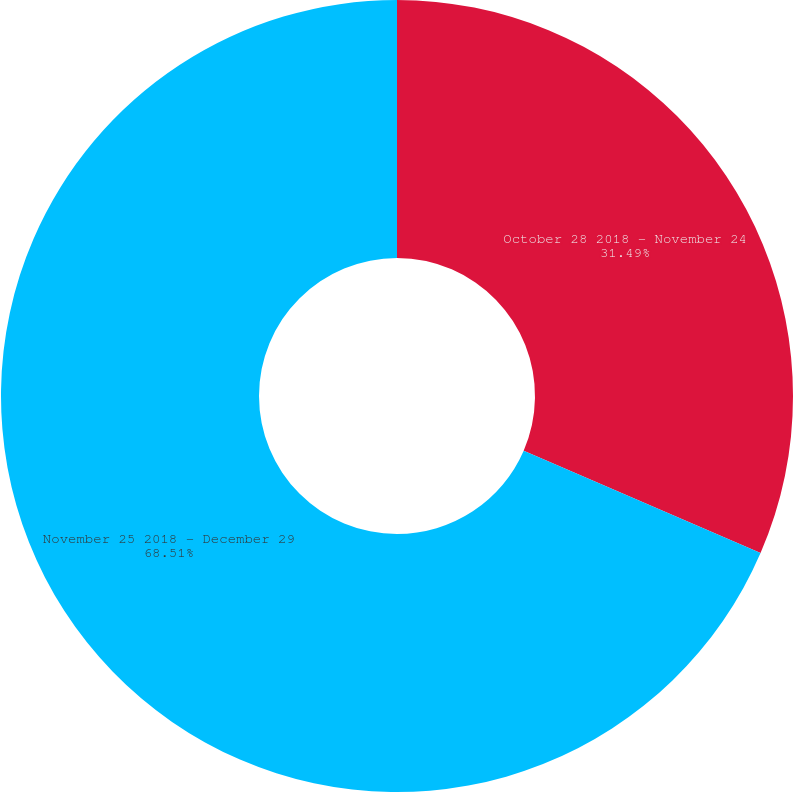Convert chart to OTSL. <chart><loc_0><loc_0><loc_500><loc_500><pie_chart><fcel>October 28 2018 - November 24<fcel>November 25 2018 - December 29<nl><fcel>31.49%<fcel>68.51%<nl></chart> 